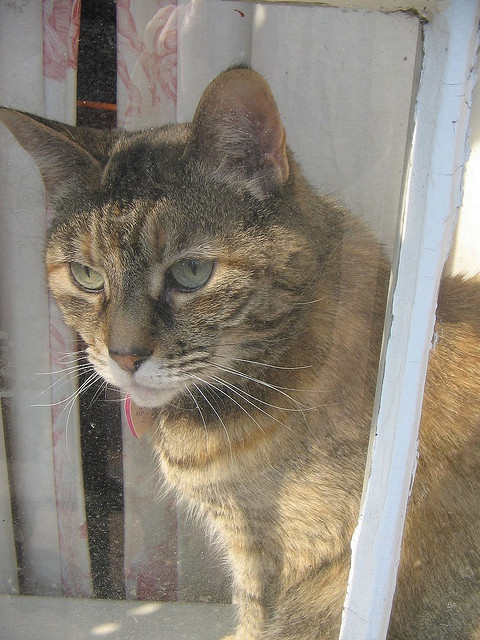Describe the objects in this image and their specific colors. I can see a cat in gray and tan tones in this image. 